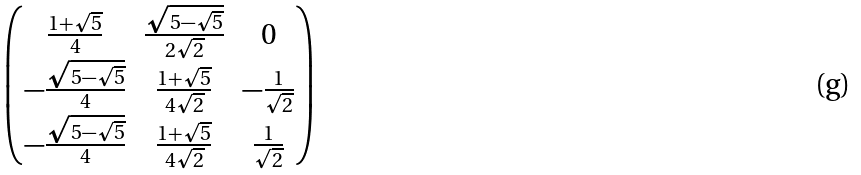<formula> <loc_0><loc_0><loc_500><loc_500>\begin{pmatrix} \frac { 1 + \sqrt { 5 } } { 4 } & \frac { \sqrt { 5 - \sqrt { 5 } } } { 2 \sqrt { 2 } } & 0 \\ - \frac { \sqrt { 5 - \sqrt { 5 } } } { 4 } & \frac { 1 + \sqrt { 5 } } { 4 \sqrt { 2 } } & - \frac { 1 } { \sqrt { 2 } } \\ - \frac { \sqrt { 5 - \sqrt { 5 } } } { 4 } & \frac { 1 + \sqrt { 5 } } { 4 \sqrt { 2 } } & \frac { 1 } { \sqrt { 2 } } \end{pmatrix}</formula> 